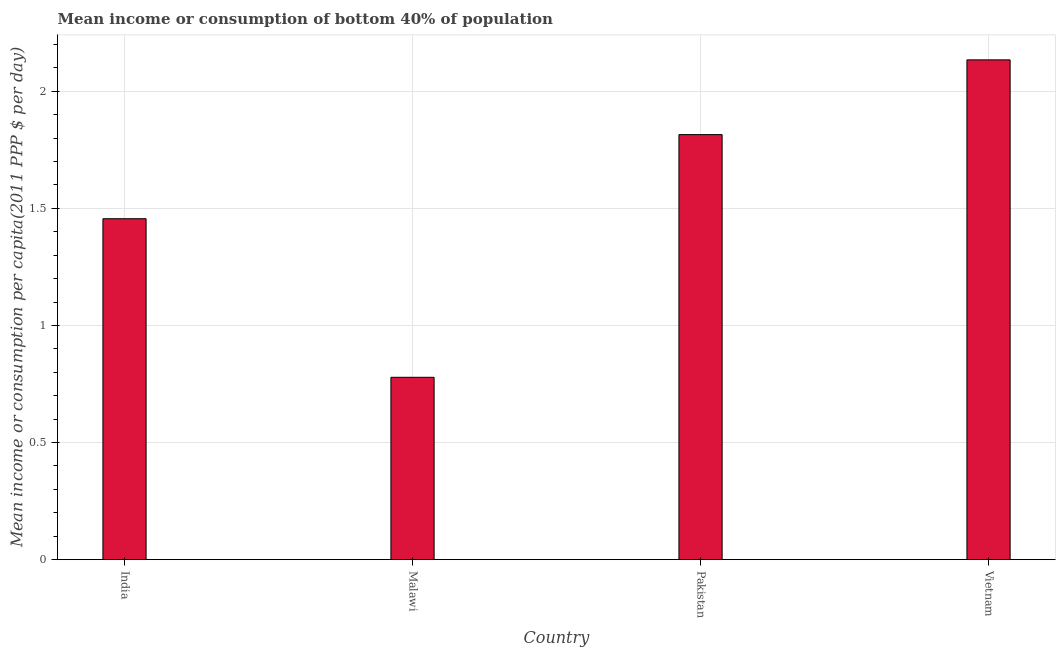What is the title of the graph?
Your response must be concise. Mean income or consumption of bottom 40% of population. What is the label or title of the Y-axis?
Provide a succinct answer. Mean income or consumption per capita(2011 PPP $ per day). What is the mean income or consumption in Vietnam?
Ensure brevity in your answer.  2.13. Across all countries, what is the maximum mean income or consumption?
Keep it short and to the point. 2.13. Across all countries, what is the minimum mean income or consumption?
Keep it short and to the point. 0.78. In which country was the mean income or consumption maximum?
Your answer should be compact. Vietnam. In which country was the mean income or consumption minimum?
Make the answer very short. Malawi. What is the sum of the mean income or consumption?
Make the answer very short. 6.18. What is the difference between the mean income or consumption in Malawi and Pakistan?
Offer a very short reply. -1.04. What is the average mean income or consumption per country?
Your answer should be compact. 1.55. What is the median mean income or consumption?
Make the answer very short. 1.64. In how many countries, is the mean income or consumption greater than 0.1 $?
Offer a terse response. 4. What is the ratio of the mean income or consumption in Pakistan to that in Vietnam?
Ensure brevity in your answer.  0.85. Is the mean income or consumption in India less than that in Malawi?
Make the answer very short. No. Is the difference between the mean income or consumption in India and Pakistan greater than the difference between any two countries?
Give a very brief answer. No. What is the difference between the highest and the second highest mean income or consumption?
Provide a short and direct response. 0.32. Is the sum of the mean income or consumption in Malawi and Vietnam greater than the maximum mean income or consumption across all countries?
Provide a short and direct response. Yes. What is the difference between the highest and the lowest mean income or consumption?
Ensure brevity in your answer.  1.36. In how many countries, is the mean income or consumption greater than the average mean income or consumption taken over all countries?
Your response must be concise. 2. How many countries are there in the graph?
Your answer should be very brief. 4. What is the difference between two consecutive major ticks on the Y-axis?
Give a very brief answer. 0.5. Are the values on the major ticks of Y-axis written in scientific E-notation?
Your answer should be compact. No. What is the Mean income or consumption per capita(2011 PPP $ per day) in India?
Make the answer very short. 1.46. What is the Mean income or consumption per capita(2011 PPP $ per day) of Malawi?
Provide a succinct answer. 0.78. What is the Mean income or consumption per capita(2011 PPP $ per day) of Pakistan?
Your response must be concise. 1.82. What is the Mean income or consumption per capita(2011 PPP $ per day) in Vietnam?
Offer a terse response. 2.13. What is the difference between the Mean income or consumption per capita(2011 PPP $ per day) in India and Malawi?
Make the answer very short. 0.68. What is the difference between the Mean income or consumption per capita(2011 PPP $ per day) in India and Pakistan?
Offer a terse response. -0.36. What is the difference between the Mean income or consumption per capita(2011 PPP $ per day) in India and Vietnam?
Keep it short and to the point. -0.68. What is the difference between the Mean income or consumption per capita(2011 PPP $ per day) in Malawi and Pakistan?
Offer a terse response. -1.04. What is the difference between the Mean income or consumption per capita(2011 PPP $ per day) in Malawi and Vietnam?
Your answer should be very brief. -1.36. What is the difference between the Mean income or consumption per capita(2011 PPP $ per day) in Pakistan and Vietnam?
Give a very brief answer. -0.32. What is the ratio of the Mean income or consumption per capita(2011 PPP $ per day) in India to that in Malawi?
Provide a succinct answer. 1.87. What is the ratio of the Mean income or consumption per capita(2011 PPP $ per day) in India to that in Pakistan?
Your answer should be compact. 0.8. What is the ratio of the Mean income or consumption per capita(2011 PPP $ per day) in India to that in Vietnam?
Provide a short and direct response. 0.68. What is the ratio of the Mean income or consumption per capita(2011 PPP $ per day) in Malawi to that in Pakistan?
Provide a short and direct response. 0.43. What is the ratio of the Mean income or consumption per capita(2011 PPP $ per day) in Malawi to that in Vietnam?
Your answer should be compact. 0.36. 